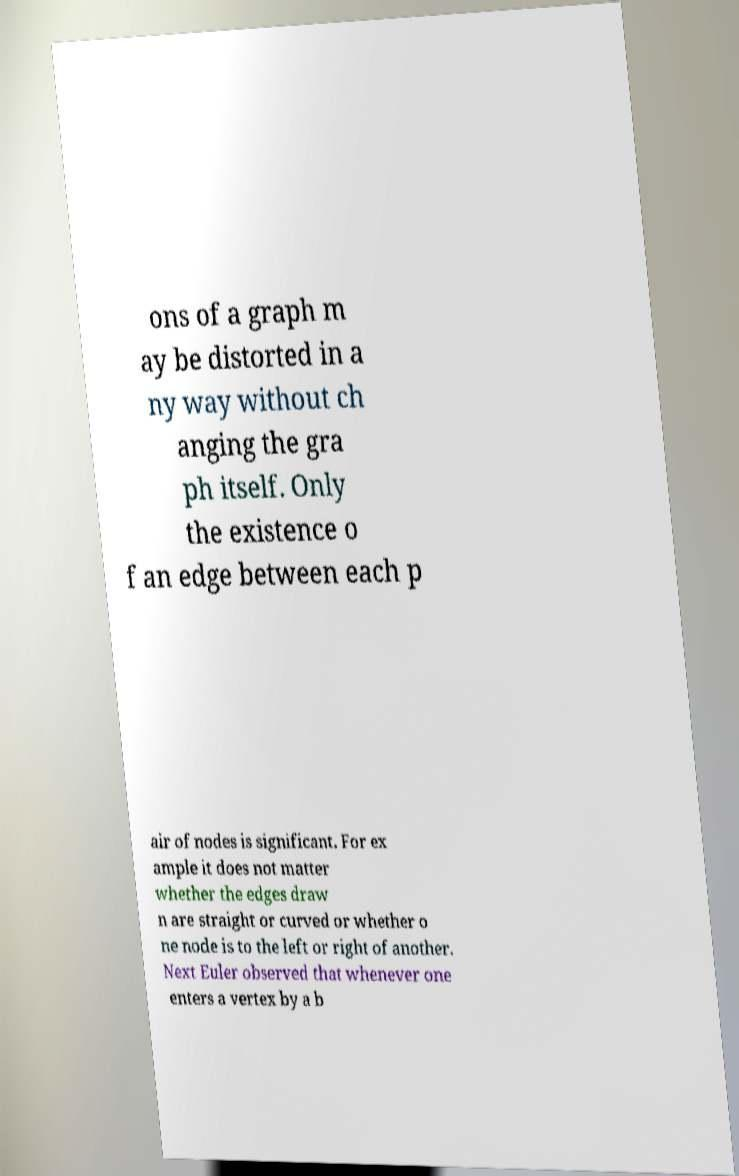Please read and relay the text visible in this image. What does it say? ons of a graph m ay be distorted in a ny way without ch anging the gra ph itself. Only the existence o f an edge between each p air of nodes is significant. For ex ample it does not matter whether the edges draw n are straight or curved or whether o ne node is to the left or right of another. Next Euler observed that whenever one enters a vertex by a b 